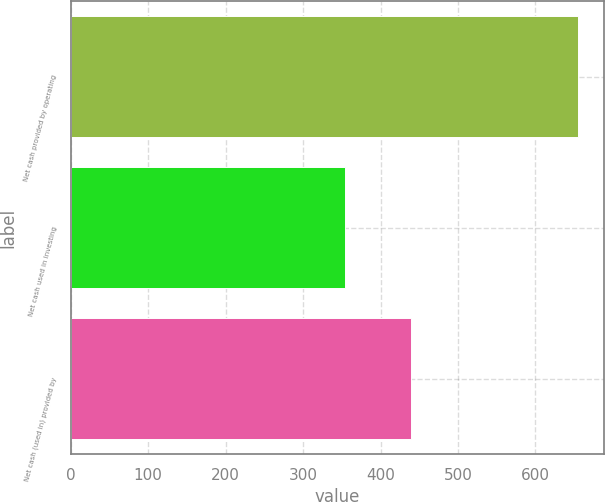<chart> <loc_0><loc_0><loc_500><loc_500><bar_chart><fcel>Net cash provided by operating<fcel>Net cash used in investing<fcel>Net cash (used in) provided by<nl><fcel>655.3<fcel>354.6<fcel>439.6<nl></chart> 